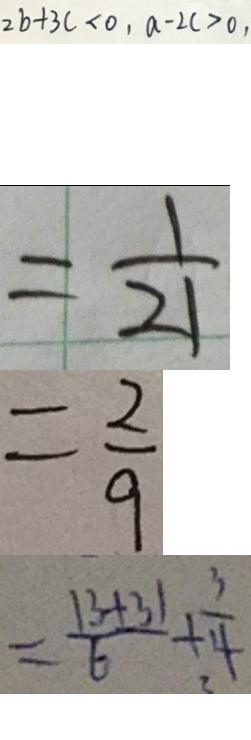<formula> <loc_0><loc_0><loc_500><loc_500>2 b + 3 c < 0 , a - 2 c > 0 , 
 = \frac { 1 } { 2 1 } 
 = \frac { 2 } { 9 } 
 = \frac { 1 3 + 3 1 } { 6 } + \frac { 3 } { 4 }</formula> 